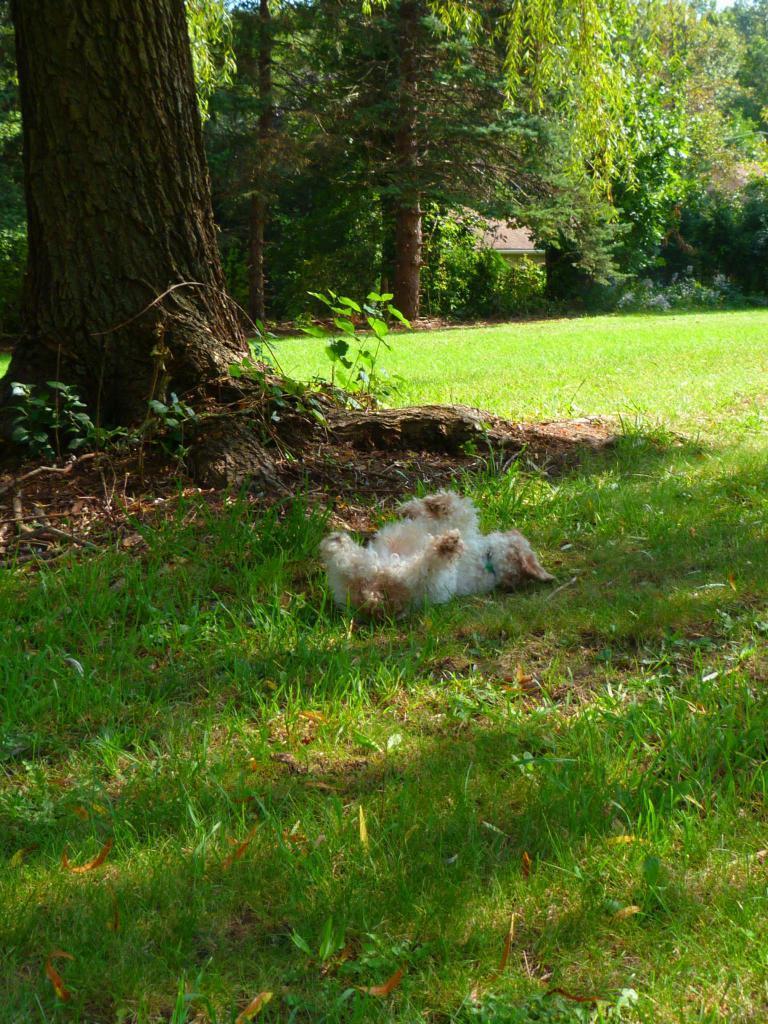Please provide a concise description of this image. In this image we can see an animal lying on the grass. In the background, we can see the trees. 